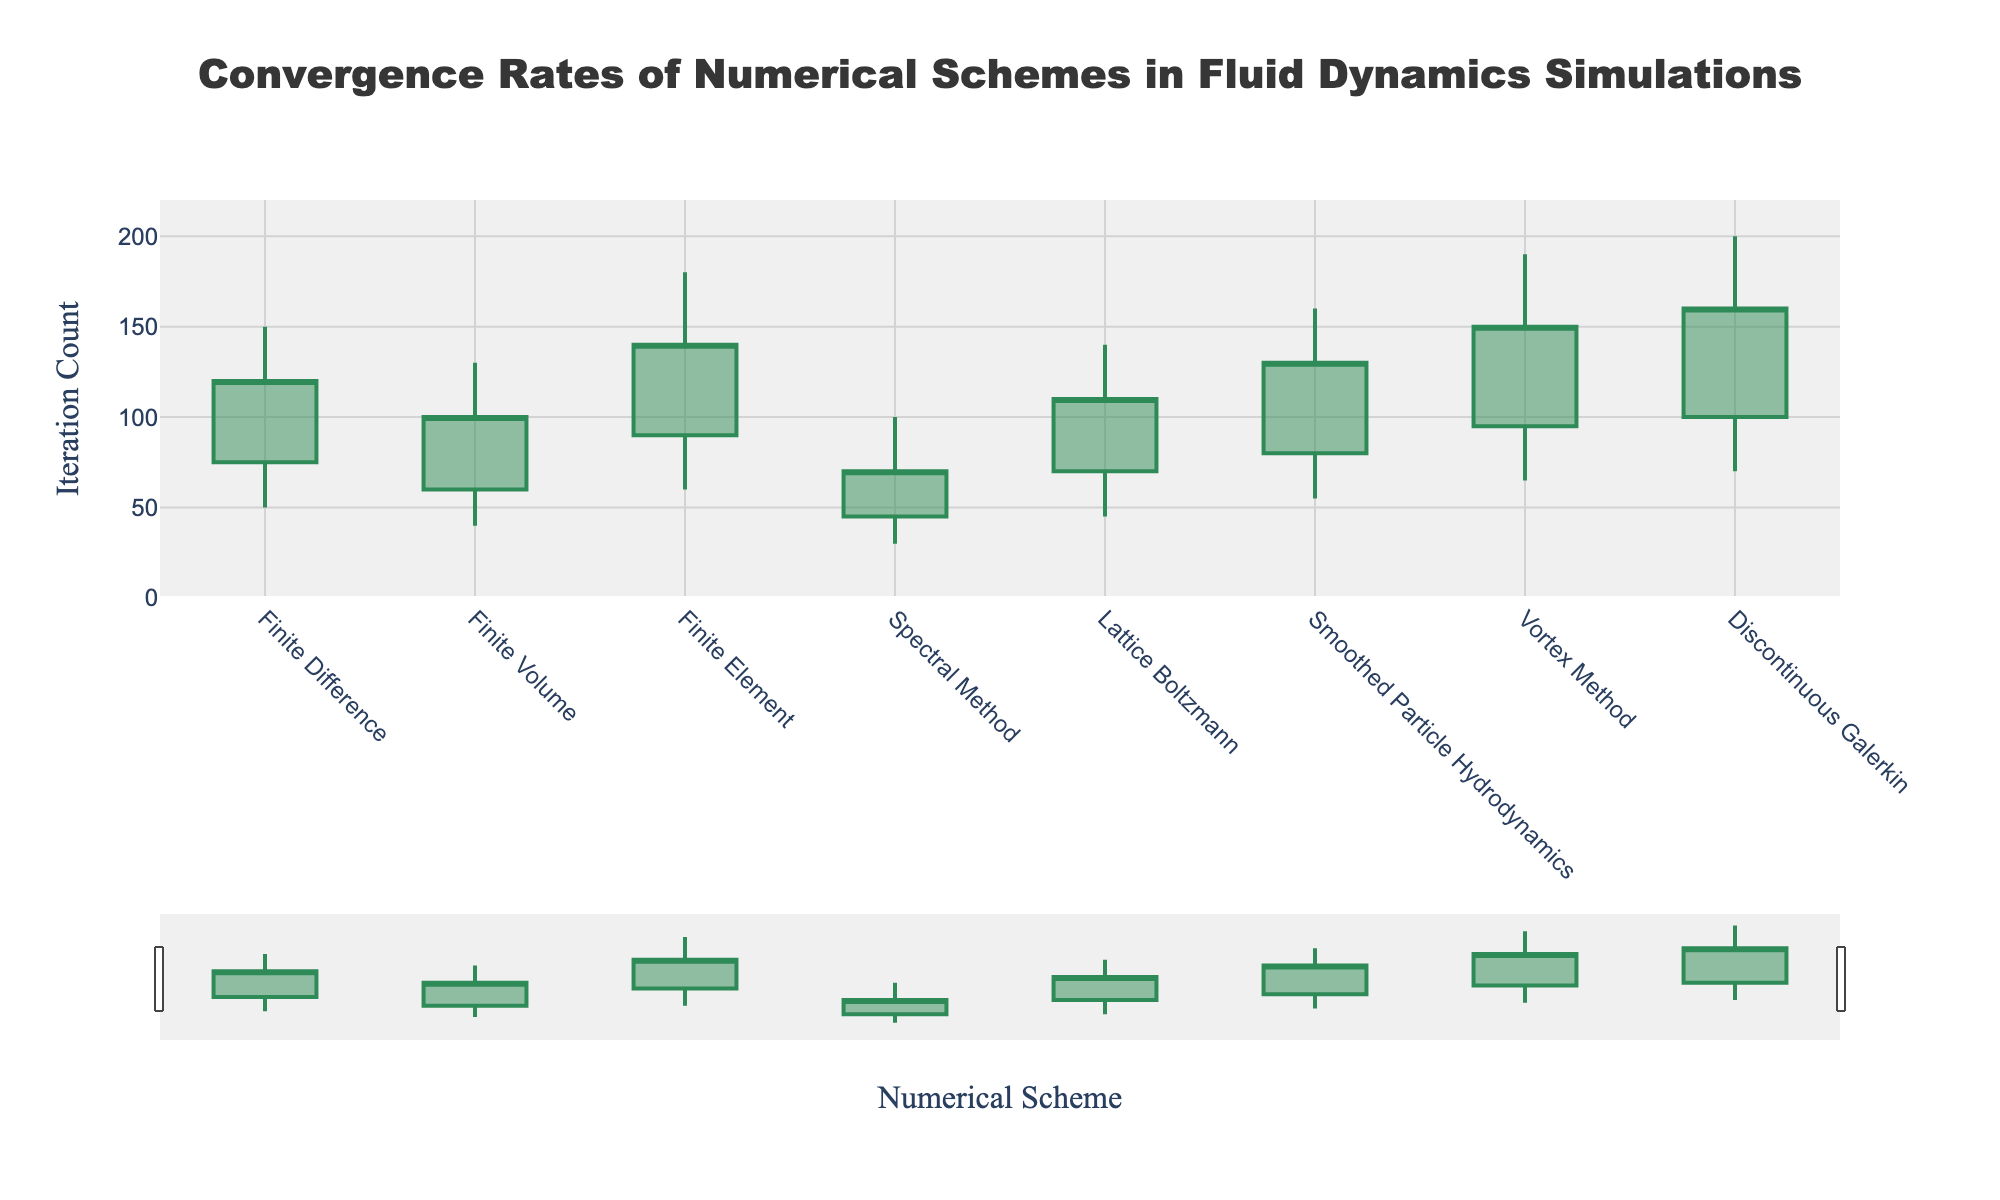Which numerical scheme has the highest maximum iterations? The maximum iterations for each scheme are indicated by the highest point of each candlestick. By observing all the highest points, the Discontinuous Galerkin scheme clearly has the highest maximum iterations of 200.
Answer: Discontinuous Galerkin What is the range of iterations required for the Spectral Method? The range of iterations is defined by the minimum and maximum iterations. For the Spectral Method, the minimum iterations are 30 and the maximum iterations are 100. Thus, the range is 100 - 30 = 70 iterations.
Answer: 70 Which scheme has the smallest range of iteration counts between minimum and maximum values? To find the smallest range, calculate the differences between maximum and minimum iterations for all schemes. The Spectral Method has the smallest range of 70 iterations (100 - 30 = 70).
Answer: Spectral Method Which numerical scheme has the widest spread between opening and closing iterations? The spread is the absolute difference between opening and closing iterations. For each scheme, compare these values. The Vortex Method shows the largest spread:
Answer: Vortex Method Which scheme has the smallest closing iterations count? Examine the closing iterations for all schemes. The Spectral Method has the smallest closing iterations count at 70.
Answer: Spectral Method 